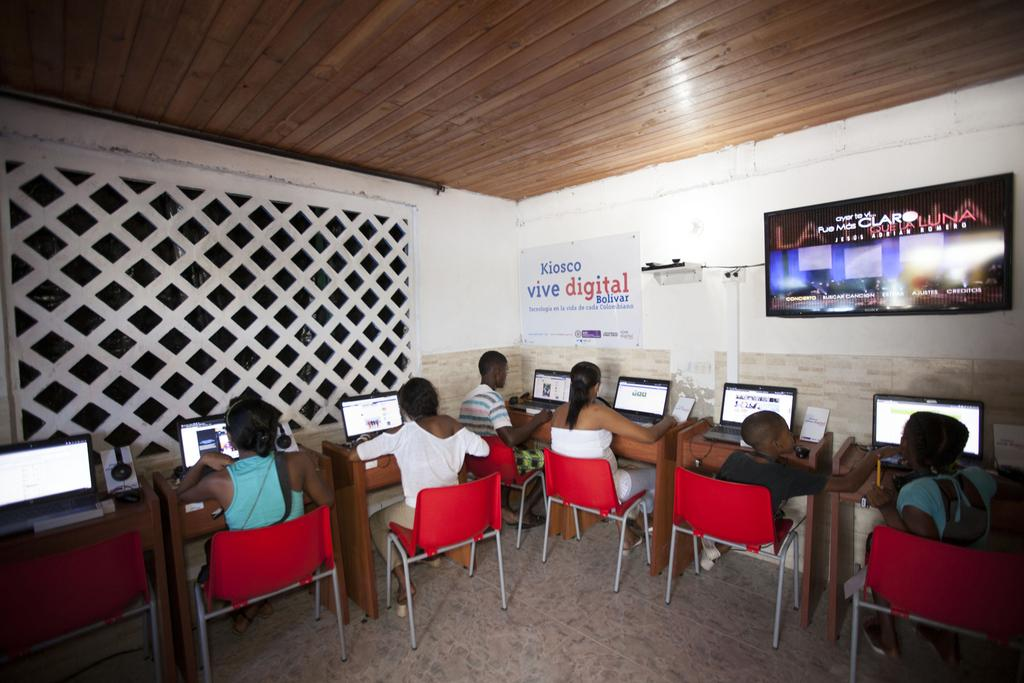How many people are in the image? There is a group of persons in the image. What are the persons doing in the image? The persons are sitting on chairs and working on systems. What can be seen on the wall in the image? There is a big TV on the wall. What type of orange is being peeled by the person in the image? There is no orange or person peeling an orange present in the image. Can you see any sails in the image? There are no sails visible in the image. 